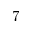Convert formula to latex. <formula><loc_0><loc_0><loc_500><loc_500>7</formula> 